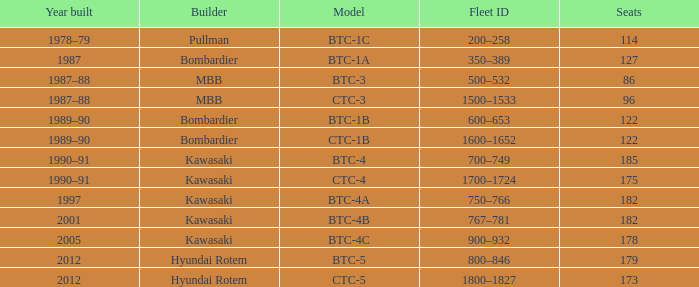What is the number of seats in the btc-5 model? 179.0. 